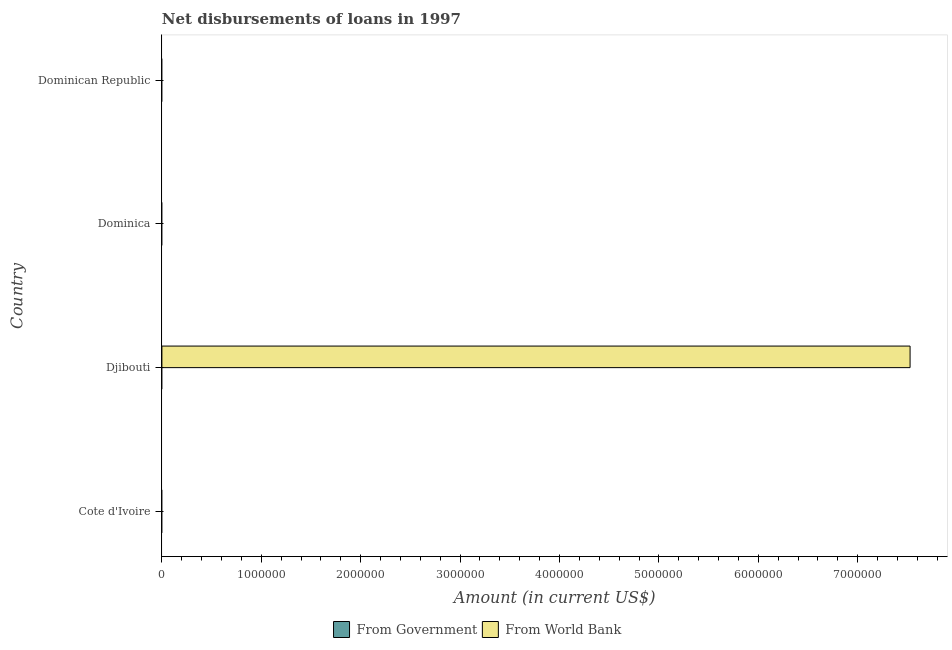How many different coloured bars are there?
Offer a very short reply. 1. How many bars are there on the 2nd tick from the top?
Provide a succinct answer. 0. What is the label of the 2nd group of bars from the top?
Provide a short and direct response. Dominica. What is the net disbursements of loan from government in Cote d'Ivoire?
Your answer should be very brief. 0. Across all countries, what is the maximum net disbursements of loan from world bank?
Ensure brevity in your answer.  7.53e+06. Across all countries, what is the minimum net disbursements of loan from government?
Offer a very short reply. 0. In which country was the net disbursements of loan from world bank maximum?
Your answer should be very brief. Djibouti. What is the total net disbursements of loan from government in the graph?
Offer a terse response. 0. What is the difference between the net disbursements of loan from government in Cote d'Ivoire and the net disbursements of loan from world bank in Djibouti?
Offer a terse response. -7.53e+06. What is the average net disbursements of loan from world bank per country?
Offer a very short reply. 1.88e+06. What is the difference between the highest and the lowest net disbursements of loan from world bank?
Your response must be concise. 7.53e+06. In how many countries, is the net disbursements of loan from government greater than the average net disbursements of loan from government taken over all countries?
Provide a short and direct response. 0. How many bars are there?
Your response must be concise. 1. What is the difference between two consecutive major ticks on the X-axis?
Your answer should be very brief. 1.00e+06. Does the graph contain any zero values?
Provide a succinct answer. Yes. Does the graph contain grids?
Your answer should be very brief. No. How are the legend labels stacked?
Your response must be concise. Horizontal. What is the title of the graph?
Offer a very short reply. Net disbursements of loans in 1997. What is the label or title of the X-axis?
Provide a short and direct response. Amount (in current US$). What is the Amount (in current US$) of From Government in Cote d'Ivoire?
Your answer should be very brief. 0. What is the Amount (in current US$) of From World Bank in Djibouti?
Offer a very short reply. 7.53e+06. What is the Amount (in current US$) in From Government in Dominica?
Ensure brevity in your answer.  0. What is the Amount (in current US$) of From Government in Dominican Republic?
Provide a succinct answer. 0. Across all countries, what is the maximum Amount (in current US$) in From World Bank?
Ensure brevity in your answer.  7.53e+06. What is the total Amount (in current US$) in From World Bank in the graph?
Offer a terse response. 7.53e+06. What is the average Amount (in current US$) of From Government per country?
Keep it short and to the point. 0. What is the average Amount (in current US$) in From World Bank per country?
Your answer should be compact. 1.88e+06. What is the difference between the highest and the lowest Amount (in current US$) in From World Bank?
Provide a short and direct response. 7.53e+06. 